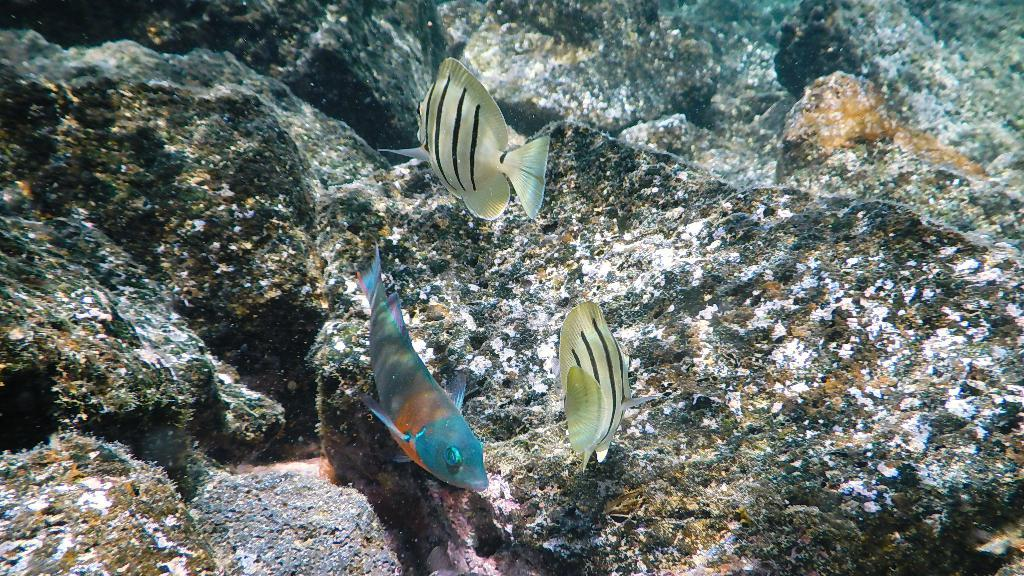How many fish are in the image? There are three fish in the image. Where are the fish located? The fish are in the water. What other objects can be seen near the fish in the image? There are stones visible beside the fish in the image. What type of spy equipment can be seen in the image? There is no spy equipment present in the image; it features three fish in the water with stones beside them. What type of wilderness can be seen in the image? The image does not depict a specific wilderness; it simply shows three fish in the water with stones beside them. 